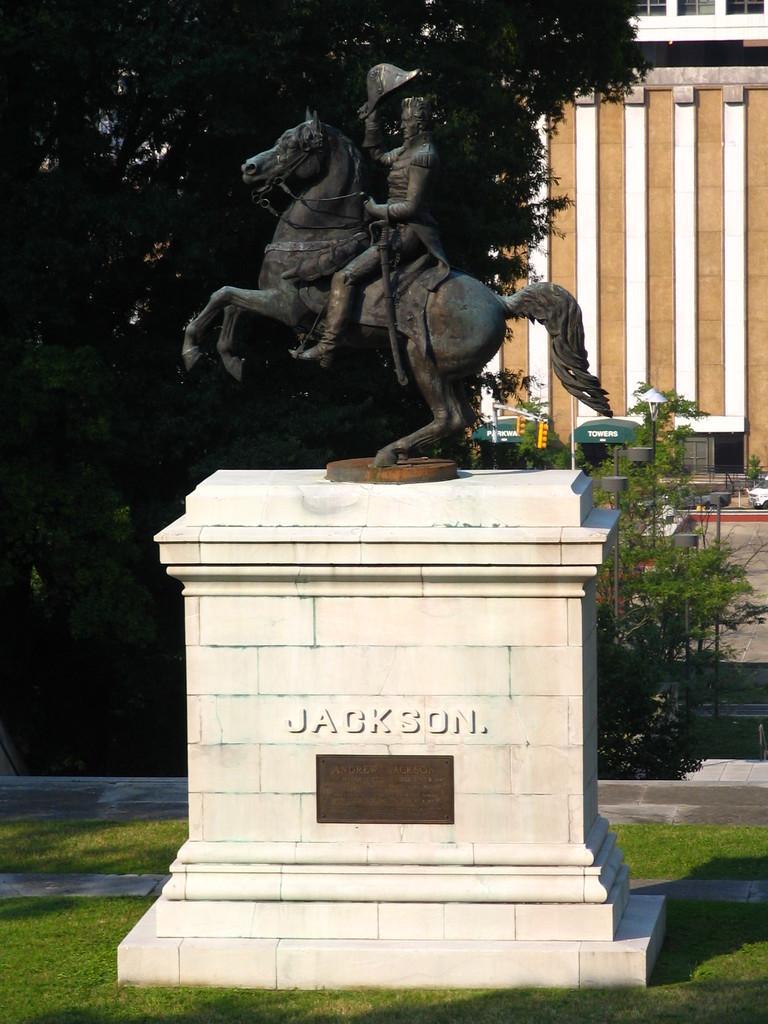Could you give a brief overview of what you see in this image? In the center of the image we can see a statue on a memorial. We can also see some grass, plants, some trees, a pole and a building. 